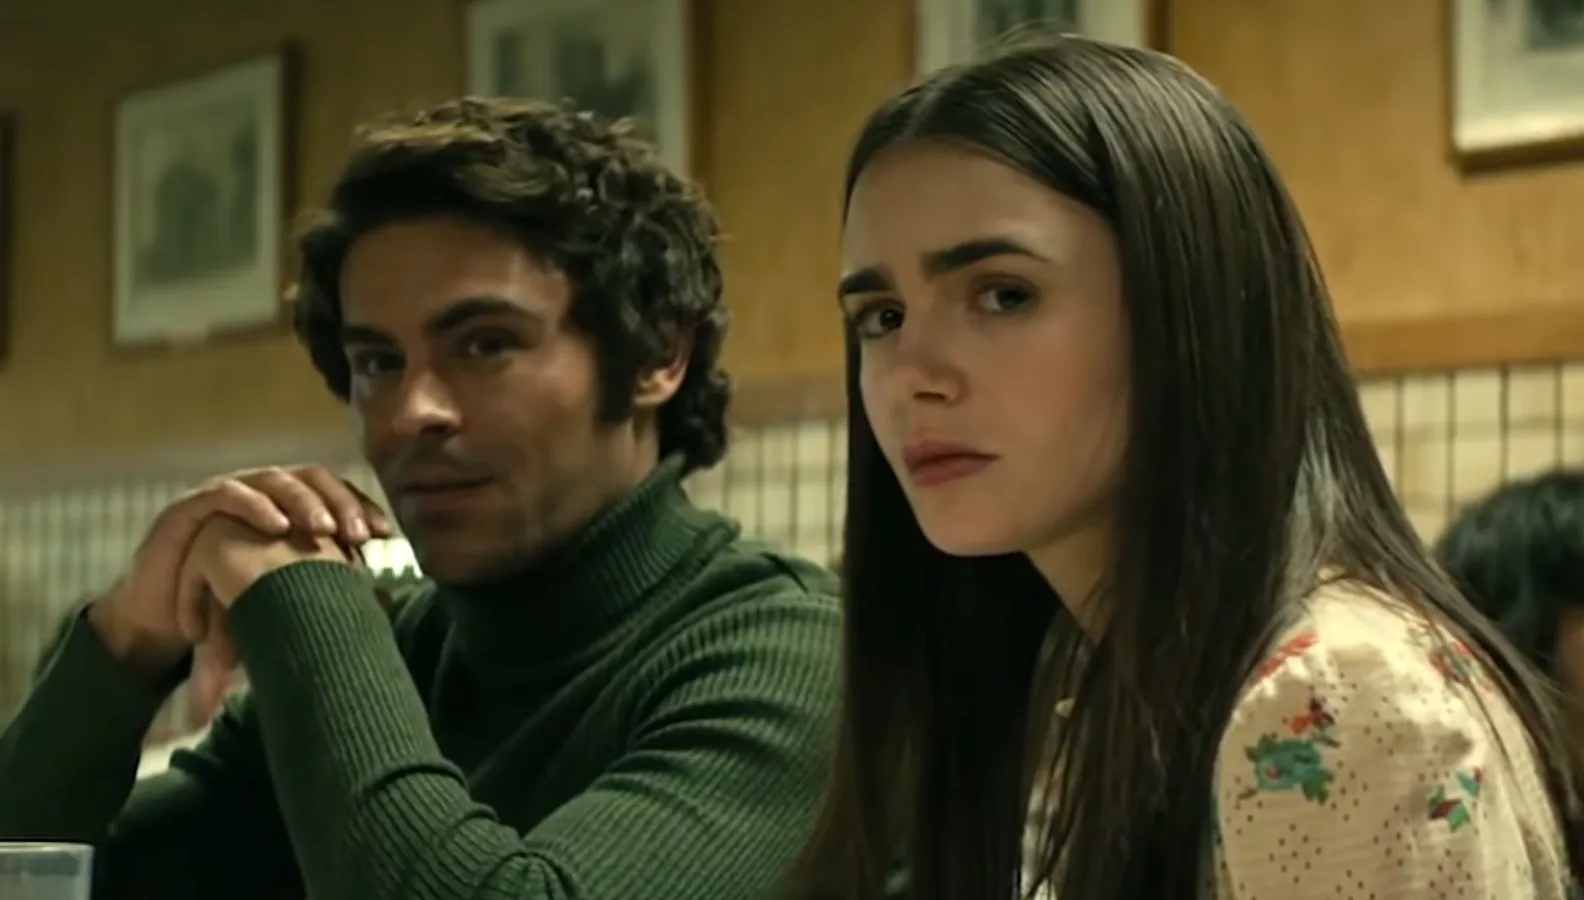If this scene were part of a psychological thriller, what could be happening between the characters? In the context of a psychological thriller, this moment could represent a pivotal conversation wherein crucial information is being revealed. The man on the left, dressed in a green turtleneck, might be a mysterious figure with a hidden agenda, while the woman could be an investigator piecing together a puzzle. Their serious expressions add to the tension; perhaps she has confronted him with incriminating evidence, and he is deliberating his next move. The atmosphere in the diner, normally a place of comfort, now becomes fraught with underlying tension, symbolizing the ambiguous moral lines and high stakes of their exchange. 